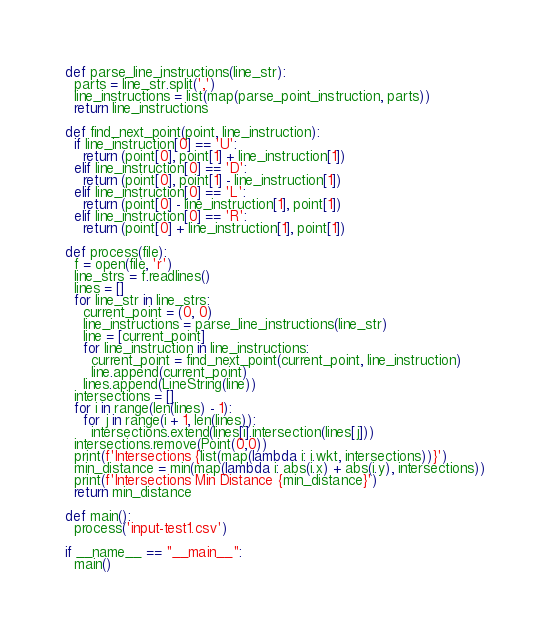<code> <loc_0><loc_0><loc_500><loc_500><_Python_>def parse_line_instructions(line_str):
  parts = line_str.split(',')
  line_instructions = list(map(parse_point_instruction, parts))
  return line_instructions

def find_next_point(point, line_instruction):
  if line_instruction[0] == 'U':
    return (point[0], point[1] + line_instruction[1])
  elif line_instruction[0] == 'D':
    return (point[0], point[1] - line_instruction[1])
  elif line_instruction[0] == 'L':
    return (point[0] - line_instruction[1], point[1])
  elif line_instruction[0] == 'R':
    return (point[0] + line_instruction[1], point[1])

def process(file):
  f = open(file, 'r')
  line_strs = f.readlines()
  lines = []
  for line_str in line_strs:
    current_point = (0, 0)
    line_instructions = parse_line_instructions(line_str)
    line = [current_point]
    for line_instruction in line_instructions:
      current_point = find_next_point(current_point, line_instruction)
      line.append(current_point)
    lines.append(LineString(line))
  intersections = []
  for i in range(len(lines) - 1):
    for j in range(i + 1, len(lines)):
      intersections.extend(lines[i].intersection(lines[j]))
  intersections.remove(Point(0,0))
  print(f'Intersections {list(map(lambda i: i.wkt, intersections))}')
  min_distance = min(map(lambda i: abs(i.x) + abs(i.y), intersections))
  print(f'Intersections Min Distance {min_distance}')
  return min_distance

def main():
  process('input-test1.csv')

if __name__ == "__main__":
  main()
</code> 